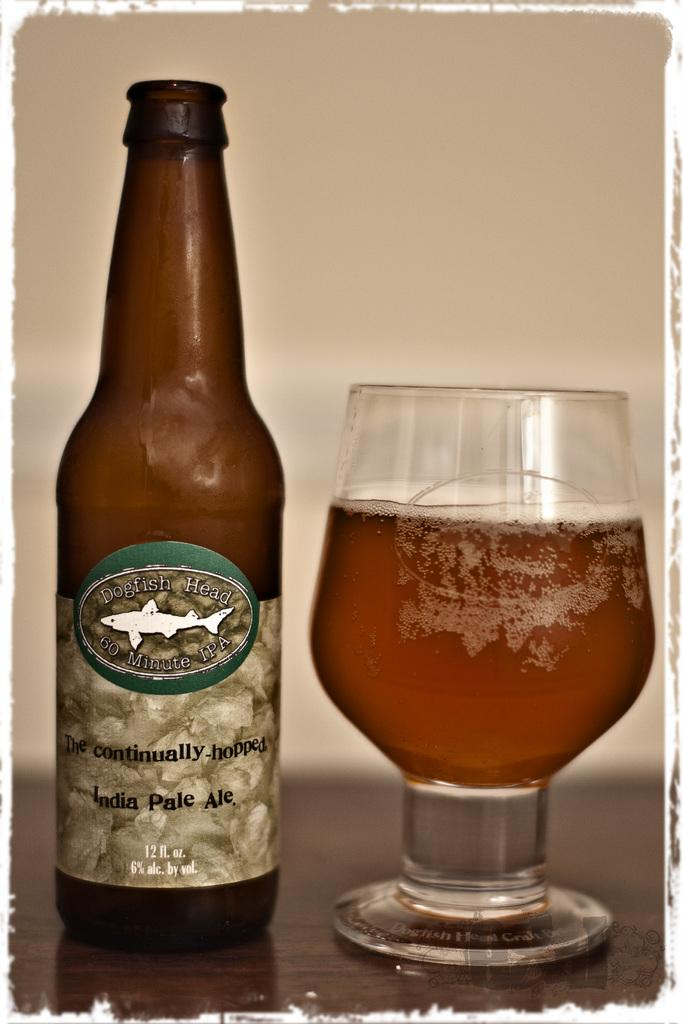<image>
Summarize the visual content of the image. A glass of Dogfish Head India Pale Ale sits on a table. 